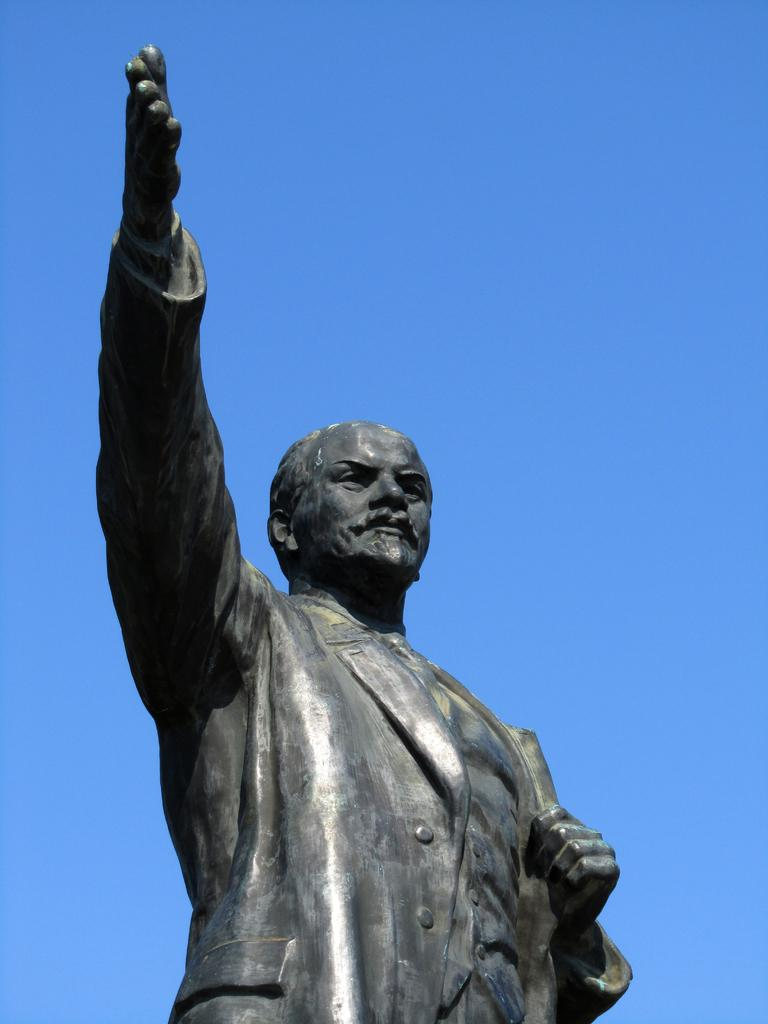What is the main subject of the image? There is a person's statue in the image. What can be seen in the background of the image? The background of the image contains a blue sky. How many visitors can be seen biting the statue in the image? There are no visitors present in the image, and therefore no one is biting the statue. What type of wash is being used to clean the statue in the image? There is no wash or cleaning activity depicted in the image; it only shows the statue and the blue sky in the background. 